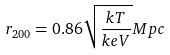Convert formula to latex. <formula><loc_0><loc_0><loc_500><loc_500>r _ { 2 0 0 } = 0 . 8 6 \sqrt { \frac { k T } { k e V } } M p c</formula> 